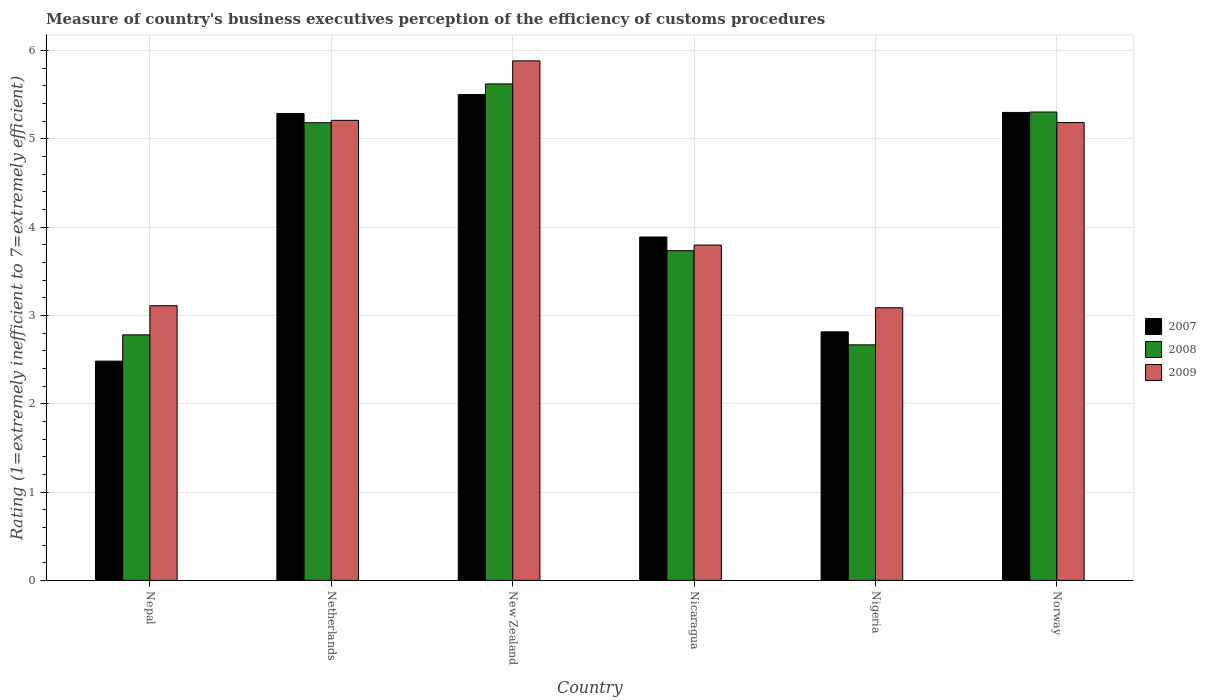Are the number of bars on each tick of the X-axis equal?
Offer a terse response. Yes. How many bars are there on the 1st tick from the right?
Your answer should be very brief. 3. What is the label of the 4th group of bars from the left?
Offer a terse response. Nicaragua. What is the rating of the efficiency of customs procedure in 2007 in Norway?
Your answer should be compact. 5.3. Across all countries, what is the maximum rating of the efficiency of customs procedure in 2009?
Keep it short and to the point. 5.88. Across all countries, what is the minimum rating of the efficiency of customs procedure in 2008?
Your answer should be compact. 2.67. In which country was the rating of the efficiency of customs procedure in 2008 maximum?
Provide a short and direct response. New Zealand. In which country was the rating of the efficiency of customs procedure in 2009 minimum?
Ensure brevity in your answer.  Nigeria. What is the total rating of the efficiency of customs procedure in 2009 in the graph?
Your answer should be compact. 26.26. What is the difference between the rating of the efficiency of customs procedure in 2007 in Netherlands and that in Norway?
Your response must be concise. -0.01. What is the difference between the rating of the efficiency of customs procedure in 2008 in New Zealand and the rating of the efficiency of customs procedure in 2009 in Norway?
Offer a terse response. 0.44. What is the average rating of the efficiency of customs procedure in 2007 per country?
Keep it short and to the point. 4.21. What is the difference between the rating of the efficiency of customs procedure of/in 2008 and rating of the efficiency of customs procedure of/in 2009 in Norway?
Offer a very short reply. 0.12. What is the ratio of the rating of the efficiency of customs procedure in 2008 in Netherlands to that in Nigeria?
Your answer should be very brief. 1.94. Is the rating of the efficiency of customs procedure in 2008 in New Zealand less than that in Nigeria?
Ensure brevity in your answer.  No. Is the difference between the rating of the efficiency of customs procedure in 2008 in Nepal and Nicaragua greater than the difference between the rating of the efficiency of customs procedure in 2009 in Nepal and Nicaragua?
Your answer should be very brief. No. What is the difference between the highest and the second highest rating of the efficiency of customs procedure in 2008?
Make the answer very short. -0.32. What is the difference between the highest and the lowest rating of the efficiency of customs procedure in 2008?
Your answer should be compact. 2.95. Is the sum of the rating of the efficiency of customs procedure in 2008 in Netherlands and Nicaragua greater than the maximum rating of the efficiency of customs procedure in 2007 across all countries?
Your answer should be compact. Yes. What does the 2nd bar from the left in Nicaragua represents?
Your answer should be compact. 2008. How many bars are there?
Your response must be concise. 18. Are the values on the major ticks of Y-axis written in scientific E-notation?
Your response must be concise. No. Does the graph contain grids?
Provide a succinct answer. Yes. Where does the legend appear in the graph?
Offer a terse response. Center right. How many legend labels are there?
Give a very brief answer. 3. What is the title of the graph?
Keep it short and to the point. Measure of country's business executives perception of the efficiency of customs procedures. What is the label or title of the Y-axis?
Your answer should be compact. Rating (1=extremely inefficient to 7=extremely efficient). What is the Rating (1=extremely inefficient to 7=extremely efficient) of 2007 in Nepal?
Your answer should be compact. 2.48. What is the Rating (1=extremely inefficient to 7=extremely efficient) of 2008 in Nepal?
Offer a very short reply. 2.78. What is the Rating (1=extremely inefficient to 7=extremely efficient) of 2009 in Nepal?
Offer a terse response. 3.11. What is the Rating (1=extremely inefficient to 7=extremely efficient) in 2007 in Netherlands?
Your answer should be very brief. 5.29. What is the Rating (1=extremely inefficient to 7=extremely efficient) in 2008 in Netherlands?
Offer a very short reply. 5.18. What is the Rating (1=extremely inefficient to 7=extremely efficient) of 2009 in Netherlands?
Offer a terse response. 5.21. What is the Rating (1=extremely inefficient to 7=extremely efficient) in 2008 in New Zealand?
Your response must be concise. 5.62. What is the Rating (1=extremely inefficient to 7=extremely efficient) of 2009 in New Zealand?
Keep it short and to the point. 5.88. What is the Rating (1=extremely inefficient to 7=extremely efficient) in 2007 in Nicaragua?
Offer a terse response. 3.89. What is the Rating (1=extremely inefficient to 7=extremely efficient) of 2008 in Nicaragua?
Your answer should be compact. 3.73. What is the Rating (1=extremely inefficient to 7=extremely efficient) of 2009 in Nicaragua?
Provide a short and direct response. 3.8. What is the Rating (1=extremely inefficient to 7=extremely efficient) of 2007 in Nigeria?
Offer a very short reply. 2.81. What is the Rating (1=extremely inefficient to 7=extremely efficient) of 2008 in Nigeria?
Provide a succinct answer. 2.67. What is the Rating (1=extremely inefficient to 7=extremely efficient) of 2009 in Nigeria?
Offer a very short reply. 3.09. What is the Rating (1=extremely inefficient to 7=extremely efficient) of 2007 in Norway?
Offer a terse response. 5.3. What is the Rating (1=extremely inefficient to 7=extremely efficient) of 2008 in Norway?
Your response must be concise. 5.3. What is the Rating (1=extremely inefficient to 7=extremely efficient) in 2009 in Norway?
Offer a terse response. 5.18. Across all countries, what is the maximum Rating (1=extremely inefficient to 7=extremely efficient) in 2008?
Offer a terse response. 5.62. Across all countries, what is the maximum Rating (1=extremely inefficient to 7=extremely efficient) in 2009?
Keep it short and to the point. 5.88. Across all countries, what is the minimum Rating (1=extremely inefficient to 7=extremely efficient) of 2007?
Offer a terse response. 2.48. Across all countries, what is the minimum Rating (1=extremely inefficient to 7=extremely efficient) of 2008?
Provide a short and direct response. 2.67. Across all countries, what is the minimum Rating (1=extremely inefficient to 7=extremely efficient) of 2009?
Keep it short and to the point. 3.09. What is the total Rating (1=extremely inefficient to 7=extremely efficient) in 2007 in the graph?
Provide a succinct answer. 25.27. What is the total Rating (1=extremely inefficient to 7=extremely efficient) of 2008 in the graph?
Give a very brief answer. 25.28. What is the total Rating (1=extremely inefficient to 7=extremely efficient) in 2009 in the graph?
Provide a short and direct response. 26.26. What is the difference between the Rating (1=extremely inefficient to 7=extremely efficient) in 2007 in Nepal and that in Netherlands?
Keep it short and to the point. -2.8. What is the difference between the Rating (1=extremely inefficient to 7=extremely efficient) of 2008 in Nepal and that in Netherlands?
Offer a terse response. -2.4. What is the difference between the Rating (1=extremely inefficient to 7=extremely efficient) in 2009 in Nepal and that in Netherlands?
Your response must be concise. -2.1. What is the difference between the Rating (1=extremely inefficient to 7=extremely efficient) of 2007 in Nepal and that in New Zealand?
Your response must be concise. -3.02. What is the difference between the Rating (1=extremely inefficient to 7=extremely efficient) in 2008 in Nepal and that in New Zealand?
Make the answer very short. -2.84. What is the difference between the Rating (1=extremely inefficient to 7=extremely efficient) of 2009 in Nepal and that in New Zealand?
Provide a succinct answer. -2.77. What is the difference between the Rating (1=extremely inefficient to 7=extremely efficient) of 2007 in Nepal and that in Nicaragua?
Offer a very short reply. -1.41. What is the difference between the Rating (1=extremely inefficient to 7=extremely efficient) in 2008 in Nepal and that in Nicaragua?
Your answer should be very brief. -0.95. What is the difference between the Rating (1=extremely inefficient to 7=extremely efficient) in 2009 in Nepal and that in Nicaragua?
Your answer should be very brief. -0.69. What is the difference between the Rating (1=extremely inefficient to 7=extremely efficient) of 2007 in Nepal and that in Nigeria?
Make the answer very short. -0.33. What is the difference between the Rating (1=extremely inefficient to 7=extremely efficient) in 2008 in Nepal and that in Nigeria?
Your answer should be compact. 0.11. What is the difference between the Rating (1=extremely inefficient to 7=extremely efficient) in 2009 in Nepal and that in Nigeria?
Offer a very short reply. 0.02. What is the difference between the Rating (1=extremely inefficient to 7=extremely efficient) of 2007 in Nepal and that in Norway?
Ensure brevity in your answer.  -2.82. What is the difference between the Rating (1=extremely inefficient to 7=extremely efficient) of 2008 in Nepal and that in Norway?
Provide a short and direct response. -2.52. What is the difference between the Rating (1=extremely inefficient to 7=extremely efficient) in 2009 in Nepal and that in Norway?
Ensure brevity in your answer.  -2.07. What is the difference between the Rating (1=extremely inefficient to 7=extremely efficient) in 2007 in Netherlands and that in New Zealand?
Your response must be concise. -0.21. What is the difference between the Rating (1=extremely inefficient to 7=extremely efficient) in 2008 in Netherlands and that in New Zealand?
Give a very brief answer. -0.44. What is the difference between the Rating (1=extremely inefficient to 7=extremely efficient) of 2009 in Netherlands and that in New Zealand?
Provide a short and direct response. -0.67. What is the difference between the Rating (1=extremely inefficient to 7=extremely efficient) of 2007 in Netherlands and that in Nicaragua?
Your answer should be compact. 1.4. What is the difference between the Rating (1=extremely inefficient to 7=extremely efficient) of 2008 in Netherlands and that in Nicaragua?
Your response must be concise. 1.45. What is the difference between the Rating (1=extremely inefficient to 7=extremely efficient) of 2009 in Netherlands and that in Nicaragua?
Provide a short and direct response. 1.41. What is the difference between the Rating (1=extremely inefficient to 7=extremely efficient) in 2007 in Netherlands and that in Nigeria?
Offer a very short reply. 2.47. What is the difference between the Rating (1=extremely inefficient to 7=extremely efficient) of 2008 in Netherlands and that in Nigeria?
Ensure brevity in your answer.  2.51. What is the difference between the Rating (1=extremely inefficient to 7=extremely efficient) in 2009 in Netherlands and that in Nigeria?
Make the answer very short. 2.12. What is the difference between the Rating (1=extremely inefficient to 7=extremely efficient) of 2007 in Netherlands and that in Norway?
Offer a terse response. -0.01. What is the difference between the Rating (1=extremely inefficient to 7=extremely efficient) of 2008 in Netherlands and that in Norway?
Your answer should be very brief. -0.12. What is the difference between the Rating (1=extremely inefficient to 7=extremely efficient) in 2009 in Netherlands and that in Norway?
Provide a short and direct response. 0.02. What is the difference between the Rating (1=extremely inefficient to 7=extremely efficient) in 2007 in New Zealand and that in Nicaragua?
Give a very brief answer. 1.61. What is the difference between the Rating (1=extremely inefficient to 7=extremely efficient) of 2008 in New Zealand and that in Nicaragua?
Offer a terse response. 1.89. What is the difference between the Rating (1=extremely inefficient to 7=extremely efficient) in 2009 in New Zealand and that in Nicaragua?
Make the answer very short. 2.09. What is the difference between the Rating (1=extremely inefficient to 7=extremely efficient) of 2007 in New Zealand and that in Nigeria?
Make the answer very short. 2.69. What is the difference between the Rating (1=extremely inefficient to 7=extremely efficient) in 2008 in New Zealand and that in Nigeria?
Provide a succinct answer. 2.95. What is the difference between the Rating (1=extremely inefficient to 7=extremely efficient) of 2009 in New Zealand and that in Nigeria?
Keep it short and to the point. 2.79. What is the difference between the Rating (1=extremely inefficient to 7=extremely efficient) in 2007 in New Zealand and that in Norway?
Make the answer very short. 0.2. What is the difference between the Rating (1=extremely inefficient to 7=extremely efficient) of 2008 in New Zealand and that in Norway?
Give a very brief answer. 0.32. What is the difference between the Rating (1=extremely inefficient to 7=extremely efficient) of 2009 in New Zealand and that in Norway?
Provide a succinct answer. 0.7. What is the difference between the Rating (1=extremely inefficient to 7=extremely efficient) in 2007 in Nicaragua and that in Nigeria?
Offer a terse response. 1.07. What is the difference between the Rating (1=extremely inefficient to 7=extremely efficient) in 2008 in Nicaragua and that in Nigeria?
Make the answer very short. 1.07. What is the difference between the Rating (1=extremely inefficient to 7=extremely efficient) in 2009 in Nicaragua and that in Nigeria?
Give a very brief answer. 0.71. What is the difference between the Rating (1=extremely inefficient to 7=extremely efficient) in 2007 in Nicaragua and that in Norway?
Provide a succinct answer. -1.41. What is the difference between the Rating (1=extremely inefficient to 7=extremely efficient) of 2008 in Nicaragua and that in Norway?
Keep it short and to the point. -1.57. What is the difference between the Rating (1=extremely inefficient to 7=extremely efficient) in 2009 in Nicaragua and that in Norway?
Your answer should be compact. -1.39. What is the difference between the Rating (1=extremely inefficient to 7=extremely efficient) of 2007 in Nigeria and that in Norway?
Provide a succinct answer. -2.48. What is the difference between the Rating (1=extremely inefficient to 7=extremely efficient) in 2008 in Nigeria and that in Norway?
Provide a short and direct response. -2.64. What is the difference between the Rating (1=extremely inefficient to 7=extremely efficient) of 2009 in Nigeria and that in Norway?
Your answer should be compact. -2.1. What is the difference between the Rating (1=extremely inefficient to 7=extremely efficient) of 2007 in Nepal and the Rating (1=extremely inefficient to 7=extremely efficient) of 2008 in Netherlands?
Offer a terse response. -2.7. What is the difference between the Rating (1=extremely inefficient to 7=extremely efficient) of 2007 in Nepal and the Rating (1=extremely inefficient to 7=extremely efficient) of 2009 in Netherlands?
Your answer should be very brief. -2.73. What is the difference between the Rating (1=extremely inefficient to 7=extremely efficient) in 2008 in Nepal and the Rating (1=extremely inefficient to 7=extremely efficient) in 2009 in Netherlands?
Offer a terse response. -2.43. What is the difference between the Rating (1=extremely inefficient to 7=extremely efficient) in 2007 in Nepal and the Rating (1=extremely inefficient to 7=extremely efficient) in 2008 in New Zealand?
Offer a terse response. -3.14. What is the difference between the Rating (1=extremely inefficient to 7=extremely efficient) of 2007 in Nepal and the Rating (1=extremely inefficient to 7=extremely efficient) of 2009 in New Zealand?
Offer a very short reply. -3.4. What is the difference between the Rating (1=extremely inefficient to 7=extremely efficient) of 2008 in Nepal and the Rating (1=extremely inefficient to 7=extremely efficient) of 2009 in New Zealand?
Your answer should be very brief. -3.1. What is the difference between the Rating (1=extremely inefficient to 7=extremely efficient) of 2007 in Nepal and the Rating (1=extremely inefficient to 7=extremely efficient) of 2008 in Nicaragua?
Your answer should be compact. -1.25. What is the difference between the Rating (1=extremely inefficient to 7=extremely efficient) in 2007 in Nepal and the Rating (1=extremely inefficient to 7=extremely efficient) in 2009 in Nicaragua?
Offer a terse response. -1.31. What is the difference between the Rating (1=extremely inefficient to 7=extremely efficient) of 2008 in Nepal and the Rating (1=extremely inefficient to 7=extremely efficient) of 2009 in Nicaragua?
Provide a short and direct response. -1.02. What is the difference between the Rating (1=extremely inefficient to 7=extremely efficient) of 2007 in Nepal and the Rating (1=extremely inefficient to 7=extremely efficient) of 2008 in Nigeria?
Your answer should be compact. -0.18. What is the difference between the Rating (1=extremely inefficient to 7=extremely efficient) of 2007 in Nepal and the Rating (1=extremely inefficient to 7=extremely efficient) of 2009 in Nigeria?
Give a very brief answer. -0.6. What is the difference between the Rating (1=extremely inefficient to 7=extremely efficient) of 2008 in Nepal and the Rating (1=extremely inefficient to 7=extremely efficient) of 2009 in Nigeria?
Ensure brevity in your answer.  -0.31. What is the difference between the Rating (1=extremely inefficient to 7=extremely efficient) in 2007 in Nepal and the Rating (1=extremely inefficient to 7=extremely efficient) in 2008 in Norway?
Give a very brief answer. -2.82. What is the difference between the Rating (1=extremely inefficient to 7=extremely efficient) in 2007 in Nepal and the Rating (1=extremely inefficient to 7=extremely efficient) in 2009 in Norway?
Provide a succinct answer. -2.7. What is the difference between the Rating (1=extremely inefficient to 7=extremely efficient) of 2008 in Nepal and the Rating (1=extremely inefficient to 7=extremely efficient) of 2009 in Norway?
Your answer should be compact. -2.4. What is the difference between the Rating (1=extremely inefficient to 7=extremely efficient) in 2007 in Netherlands and the Rating (1=extremely inefficient to 7=extremely efficient) in 2008 in New Zealand?
Keep it short and to the point. -0.33. What is the difference between the Rating (1=extremely inefficient to 7=extremely efficient) in 2007 in Netherlands and the Rating (1=extremely inefficient to 7=extremely efficient) in 2009 in New Zealand?
Offer a very short reply. -0.6. What is the difference between the Rating (1=extremely inefficient to 7=extremely efficient) of 2008 in Netherlands and the Rating (1=extremely inefficient to 7=extremely efficient) of 2009 in New Zealand?
Your answer should be compact. -0.7. What is the difference between the Rating (1=extremely inefficient to 7=extremely efficient) in 2007 in Netherlands and the Rating (1=extremely inefficient to 7=extremely efficient) in 2008 in Nicaragua?
Your answer should be very brief. 1.55. What is the difference between the Rating (1=extremely inefficient to 7=extremely efficient) in 2007 in Netherlands and the Rating (1=extremely inefficient to 7=extremely efficient) in 2009 in Nicaragua?
Your answer should be compact. 1.49. What is the difference between the Rating (1=extremely inefficient to 7=extremely efficient) in 2008 in Netherlands and the Rating (1=extremely inefficient to 7=extremely efficient) in 2009 in Nicaragua?
Provide a succinct answer. 1.39. What is the difference between the Rating (1=extremely inefficient to 7=extremely efficient) in 2007 in Netherlands and the Rating (1=extremely inefficient to 7=extremely efficient) in 2008 in Nigeria?
Your answer should be compact. 2.62. What is the difference between the Rating (1=extremely inefficient to 7=extremely efficient) of 2007 in Netherlands and the Rating (1=extremely inefficient to 7=extremely efficient) of 2009 in Nigeria?
Your answer should be very brief. 2.2. What is the difference between the Rating (1=extremely inefficient to 7=extremely efficient) in 2008 in Netherlands and the Rating (1=extremely inefficient to 7=extremely efficient) in 2009 in Nigeria?
Your response must be concise. 2.1. What is the difference between the Rating (1=extremely inefficient to 7=extremely efficient) of 2007 in Netherlands and the Rating (1=extremely inefficient to 7=extremely efficient) of 2008 in Norway?
Offer a very short reply. -0.02. What is the difference between the Rating (1=extremely inefficient to 7=extremely efficient) of 2007 in Netherlands and the Rating (1=extremely inefficient to 7=extremely efficient) of 2009 in Norway?
Provide a succinct answer. 0.1. What is the difference between the Rating (1=extremely inefficient to 7=extremely efficient) in 2008 in Netherlands and the Rating (1=extremely inefficient to 7=extremely efficient) in 2009 in Norway?
Your answer should be very brief. -0. What is the difference between the Rating (1=extremely inefficient to 7=extremely efficient) in 2007 in New Zealand and the Rating (1=extremely inefficient to 7=extremely efficient) in 2008 in Nicaragua?
Make the answer very short. 1.77. What is the difference between the Rating (1=extremely inefficient to 7=extremely efficient) in 2007 in New Zealand and the Rating (1=extremely inefficient to 7=extremely efficient) in 2009 in Nicaragua?
Your answer should be very brief. 1.7. What is the difference between the Rating (1=extremely inefficient to 7=extremely efficient) of 2008 in New Zealand and the Rating (1=extremely inefficient to 7=extremely efficient) of 2009 in Nicaragua?
Make the answer very short. 1.82. What is the difference between the Rating (1=extremely inefficient to 7=extremely efficient) in 2007 in New Zealand and the Rating (1=extremely inefficient to 7=extremely efficient) in 2008 in Nigeria?
Your answer should be very brief. 2.83. What is the difference between the Rating (1=extremely inefficient to 7=extremely efficient) of 2007 in New Zealand and the Rating (1=extremely inefficient to 7=extremely efficient) of 2009 in Nigeria?
Provide a succinct answer. 2.41. What is the difference between the Rating (1=extremely inefficient to 7=extremely efficient) in 2008 in New Zealand and the Rating (1=extremely inefficient to 7=extremely efficient) in 2009 in Nigeria?
Provide a short and direct response. 2.53. What is the difference between the Rating (1=extremely inefficient to 7=extremely efficient) in 2007 in New Zealand and the Rating (1=extremely inefficient to 7=extremely efficient) in 2008 in Norway?
Give a very brief answer. 0.2. What is the difference between the Rating (1=extremely inefficient to 7=extremely efficient) of 2007 in New Zealand and the Rating (1=extremely inefficient to 7=extremely efficient) of 2009 in Norway?
Your response must be concise. 0.32. What is the difference between the Rating (1=extremely inefficient to 7=extremely efficient) in 2008 in New Zealand and the Rating (1=extremely inefficient to 7=extremely efficient) in 2009 in Norway?
Provide a short and direct response. 0.44. What is the difference between the Rating (1=extremely inefficient to 7=extremely efficient) in 2007 in Nicaragua and the Rating (1=extremely inefficient to 7=extremely efficient) in 2008 in Nigeria?
Your answer should be very brief. 1.22. What is the difference between the Rating (1=extremely inefficient to 7=extremely efficient) of 2007 in Nicaragua and the Rating (1=extremely inefficient to 7=extremely efficient) of 2009 in Nigeria?
Your answer should be very brief. 0.8. What is the difference between the Rating (1=extremely inefficient to 7=extremely efficient) of 2008 in Nicaragua and the Rating (1=extremely inefficient to 7=extremely efficient) of 2009 in Nigeria?
Give a very brief answer. 0.65. What is the difference between the Rating (1=extremely inefficient to 7=extremely efficient) of 2007 in Nicaragua and the Rating (1=extremely inefficient to 7=extremely efficient) of 2008 in Norway?
Offer a very short reply. -1.41. What is the difference between the Rating (1=extremely inefficient to 7=extremely efficient) of 2007 in Nicaragua and the Rating (1=extremely inefficient to 7=extremely efficient) of 2009 in Norway?
Offer a terse response. -1.3. What is the difference between the Rating (1=extremely inefficient to 7=extremely efficient) of 2008 in Nicaragua and the Rating (1=extremely inefficient to 7=extremely efficient) of 2009 in Norway?
Offer a terse response. -1.45. What is the difference between the Rating (1=extremely inefficient to 7=extremely efficient) in 2007 in Nigeria and the Rating (1=extremely inefficient to 7=extremely efficient) in 2008 in Norway?
Your response must be concise. -2.49. What is the difference between the Rating (1=extremely inefficient to 7=extremely efficient) of 2007 in Nigeria and the Rating (1=extremely inefficient to 7=extremely efficient) of 2009 in Norway?
Your response must be concise. -2.37. What is the difference between the Rating (1=extremely inefficient to 7=extremely efficient) in 2008 in Nigeria and the Rating (1=extremely inefficient to 7=extremely efficient) in 2009 in Norway?
Offer a terse response. -2.52. What is the average Rating (1=extremely inefficient to 7=extremely efficient) in 2007 per country?
Offer a very short reply. 4.21. What is the average Rating (1=extremely inefficient to 7=extremely efficient) in 2008 per country?
Ensure brevity in your answer.  4.21. What is the average Rating (1=extremely inefficient to 7=extremely efficient) of 2009 per country?
Your answer should be very brief. 4.38. What is the difference between the Rating (1=extremely inefficient to 7=extremely efficient) of 2007 and Rating (1=extremely inefficient to 7=extremely efficient) of 2008 in Nepal?
Make the answer very short. -0.3. What is the difference between the Rating (1=extremely inefficient to 7=extremely efficient) in 2007 and Rating (1=extremely inefficient to 7=extremely efficient) in 2009 in Nepal?
Make the answer very short. -0.63. What is the difference between the Rating (1=extremely inefficient to 7=extremely efficient) of 2008 and Rating (1=extremely inefficient to 7=extremely efficient) of 2009 in Nepal?
Provide a succinct answer. -0.33. What is the difference between the Rating (1=extremely inefficient to 7=extremely efficient) in 2007 and Rating (1=extremely inefficient to 7=extremely efficient) in 2008 in Netherlands?
Your answer should be compact. 0.1. What is the difference between the Rating (1=extremely inefficient to 7=extremely efficient) in 2007 and Rating (1=extremely inefficient to 7=extremely efficient) in 2009 in Netherlands?
Make the answer very short. 0.08. What is the difference between the Rating (1=extremely inefficient to 7=extremely efficient) in 2008 and Rating (1=extremely inefficient to 7=extremely efficient) in 2009 in Netherlands?
Offer a terse response. -0.03. What is the difference between the Rating (1=extremely inefficient to 7=extremely efficient) in 2007 and Rating (1=extremely inefficient to 7=extremely efficient) in 2008 in New Zealand?
Give a very brief answer. -0.12. What is the difference between the Rating (1=extremely inefficient to 7=extremely efficient) in 2007 and Rating (1=extremely inefficient to 7=extremely efficient) in 2009 in New Zealand?
Your answer should be very brief. -0.38. What is the difference between the Rating (1=extremely inefficient to 7=extremely efficient) in 2008 and Rating (1=extremely inefficient to 7=extremely efficient) in 2009 in New Zealand?
Provide a succinct answer. -0.26. What is the difference between the Rating (1=extremely inefficient to 7=extremely efficient) of 2007 and Rating (1=extremely inefficient to 7=extremely efficient) of 2008 in Nicaragua?
Make the answer very short. 0.15. What is the difference between the Rating (1=extremely inefficient to 7=extremely efficient) in 2007 and Rating (1=extremely inefficient to 7=extremely efficient) in 2009 in Nicaragua?
Give a very brief answer. 0.09. What is the difference between the Rating (1=extremely inefficient to 7=extremely efficient) of 2008 and Rating (1=extremely inefficient to 7=extremely efficient) of 2009 in Nicaragua?
Provide a succinct answer. -0.06. What is the difference between the Rating (1=extremely inefficient to 7=extremely efficient) of 2007 and Rating (1=extremely inefficient to 7=extremely efficient) of 2008 in Nigeria?
Your answer should be very brief. 0.15. What is the difference between the Rating (1=extremely inefficient to 7=extremely efficient) in 2007 and Rating (1=extremely inefficient to 7=extremely efficient) in 2009 in Nigeria?
Your answer should be compact. -0.27. What is the difference between the Rating (1=extremely inefficient to 7=extremely efficient) in 2008 and Rating (1=extremely inefficient to 7=extremely efficient) in 2009 in Nigeria?
Provide a short and direct response. -0.42. What is the difference between the Rating (1=extremely inefficient to 7=extremely efficient) of 2007 and Rating (1=extremely inefficient to 7=extremely efficient) of 2008 in Norway?
Provide a short and direct response. -0. What is the difference between the Rating (1=extremely inefficient to 7=extremely efficient) of 2007 and Rating (1=extremely inefficient to 7=extremely efficient) of 2009 in Norway?
Make the answer very short. 0.11. What is the difference between the Rating (1=extremely inefficient to 7=extremely efficient) in 2008 and Rating (1=extremely inefficient to 7=extremely efficient) in 2009 in Norway?
Provide a succinct answer. 0.12. What is the ratio of the Rating (1=extremely inefficient to 7=extremely efficient) of 2007 in Nepal to that in Netherlands?
Make the answer very short. 0.47. What is the ratio of the Rating (1=extremely inefficient to 7=extremely efficient) in 2008 in Nepal to that in Netherlands?
Keep it short and to the point. 0.54. What is the ratio of the Rating (1=extremely inefficient to 7=extremely efficient) of 2009 in Nepal to that in Netherlands?
Your answer should be very brief. 0.6. What is the ratio of the Rating (1=extremely inefficient to 7=extremely efficient) in 2007 in Nepal to that in New Zealand?
Make the answer very short. 0.45. What is the ratio of the Rating (1=extremely inefficient to 7=extremely efficient) of 2008 in Nepal to that in New Zealand?
Keep it short and to the point. 0.49. What is the ratio of the Rating (1=extremely inefficient to 7=extremely efficient) of 2009 in Nepal to that in New Zealand?
Give a very brief answer. 0.53. What is the ratio of the Rating (1=extremely inefficient to 7=extremely efficient) in 2007 in Nepal to that in Nicaragua?
Keep it short and to the point. 0.64. What is the ratio of the Rating (1=extremely inefficient to 7=extremely efficient) of 2008 in Nepal to that in Nicaragua?
Make the answer very short. 0.74. What is the ratio of the Rating (1=extremely inefficient to 7=extremely efficient) in 2009 in Nepal to that in Nicaragua?
Keep it short and to the point. 0.82. What is the ratio of the Rating (1=extremely inefficient to 7=extremely efficient) of 2007 in Nepal to that in Nigeria?
Give a very brief answer. 0.88. What is the ratio of the Rating (1=extremely inefficient to 7=extremely efficient) of 2008 in Nepal to that in Nigeria?
Give a very brief answer. 1.04. What is the ratio of the Rating (1=extremely inefficient to 7=extremely efficient) of 2009 in Nepal to that in Nigeria?
Keep it short and to the point. 1.01. What is the ratio of the Rating (1=extremely inefficient to 7=extremely efficient) of 2007 in Nepal to that in Norway?
Your response must be concise. 0.47. What is the ratio of the Rating (1=extremely inefficient to 7=extremely efficient) of 2008 in Nepal to that in Norway?
Give a very brief answer. 0.52. What is the ratio of the Rating (1=extremely inefficient to 7=extremely efficient) of 2009 in Nepal to that in Norway?
Keep it short and to the point. 0.6. What is the ratio of the Rating (1=extremely inefficient to 7=extremely efficient) of 2008 in Netherlands to that in New Zealand?
Provide a succinct answer. 0.92. What is the ratio of the Rating (1=extremely inefficient to 7=extremely efficient) of 2009 in Netherlands to that in New Zealand?
Give a very brief answer. 0.89. What is the ratio of the Rating (1=extremely inefficient to 7=extremely efficient) of 2007 in Netherlands to that in Nicaragua?
Provide a succinct answer. 1.36. What is the ratio of the Rating (1=extremely inefficient to 7=extremely efficient) in 2008 in Netherlands to that in Nicaragua?
Your answer should be very brief. 1.39. What is the ratio of the Rating (1=extremely inefficient to 7=extremely efficient) of 2009 in Netherlands to that in Nicaragua?
Your response must be concise. 1.37. What is the ratio of the Rating (1=extremely inefficient to 7=extremely efficient) in 2007 in Netherlands to that in Nigeria?
Give a very brief answer. 1.88. What is the ratio of the Rating (1=extremely inefficient to 7=extremely efficient) in 2008 in Netherlands to that in Nigeria?
Your answer should be very brief. 1.94. What is the ratio of the Rating (1=extremely inefficient to 7=extremely efficient) of 2009 in Netherlands to that in Nigeria?
Ensure brevity in your answer.  1.69. What is the ratio of the Rating (1=extremely inefficient to 7=extremely efficient) in 2008 in Netherlands to that in Norway?
Make the answer very short. 0.98. What is the ratio of the Rating (1=extremely inefficient to 7=extremely efficient) of 2007 in New Zealand to that in Nicaragua?
Provide a succinct answer. 1.41. What is the ratio of the Rating (1=extremely inefficient to 7=extremely efficient) in 2008 in New Zealand to that in Nicaragua?
Your answer should be compact. 1.51. What is the ratio of the Rating (1=extremely inefficient to 7=extremely efficient) in 2009 in New Zealand to that in Nicaragua?
Offer a very short reply. 1.55. What is the ratio of the Rating (1=extremely inefficient to 7=extremely efficient) of 2007 in New Zealand to that in Nigeria?
Provide a short and direct response. 1.96. What is the ratio of the Rating (1=extremely inefficient to 7=extremely efficient) in 2008 in New Zealand to that in Nigeria?
Offer a terse response. 2.11. What is the ratio of the Rating (1=extremely inefficient to 7=extremely efficient) of 2009 in New Zealand to that in Nigeria?
Provide a short and direct response. 1.91. What is the ratio of the Rating (1=extremely inefficient to 7=extremely efficient) of 2007 in New Zealand to that in Norway?
Keep it short and to the point. 1.04. What is the ratio of the Rating (1=extremely inefficient to 7=extremely efficient) in 2008 in New Zealand to that in Norway?
Keep it short and to the point. 1.06. What is the ratio of the Rating (1=extremely inefficient to 7=extremely efficient) of 2009 in New Zealand to that in Norway?
Give a very brief answer. 1.13. What is the ratio of the Rating (1=extremely inefficient to 7=extremely efficient) in 2007 in Nicaragua to that in Nigeria?
Give a very brief answer. 1.38. What is the ratio of the Rating (1=extremely inefficient to 7=extremely efficient) in 2008 in Nicaragua to that in Nigeria?
Your answer should be compact. 1.4. What is the ratio of the Rating (1=extremely inefficient to 7=extremely efficient) in 2009 in Nicaragua to that in Nigeria?
Your answer should be compact. 1.23. What is the ratio of the Rating (1=extremely inefficient to 7=extremely efficient) of 2007 in Nicaragua to that in Norway?
Offer a very short reply. 0.73. What is the ratio of the Rating (1=extremely inefficient to 7=extremely efficient) in 2008 in Nicaragua to that in Norway?
Your answer should be compact. 0.7. What is the ratio of the Rating (1=extremely inefficient to 7=extremely efficient) in 2009 in Nicaragua to that in Norway?
Make the answer very short. 0.73. What is the ratio of the Rating (1=extremely inefficient to 7=extremely efficient) in 2007 in Nigeria to that in Norway?
Your response must be concise. 0.53. What is the ratio of the Rating (1=extremely inefficient to 7=extremely efficient) in 2008 in Nigeria to that in Norway?
Make the answer very short. 0.5. What is the ratio of the Rating (1=extremely inefficient to 7=extremely efficient) in 2009 in Nigeria to that in Norway?
Give a very brief answer. 0.6. What is the difference between the highest and the second highest Rating (1=extremely inefficient to 7=extremely efficient) in 2007?
Give a very brief answer. 0.2. What is the difference between the highest and the second highest Rating (1=extremely inefficient to 7=extremely efficient) in 2008?
Your response must be concise. 0.32. What is the difference between the highest and the second highest Rating (1=extremely inefficient to 7=extremely efficient) in 2009?
Provide a short and direct response. 0.67. What is the difference between the highest and the lowest Rating (1=extremely inefficient to 7=extremely efficient) of 2007?
Make the answer very short. 3.02. What is the difference between the highest and the lowest Rating (1=extremely inefficient to 7=extremely efficient) of 2008?
Keep it short and to the point. 2.95. What is the difference between the highest and the lowest Rating (1=extremely inefficient to 7=extremely efficient) in 2009?
Provide a succinct answer. 2.79. 